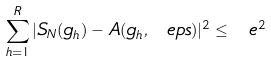Convert formula to latex. <formula><loc_0><loc_0><loc_500><loc_500>\sum _ { h = 1 } ^ { R } | S _ { N } ( g _ { h } ) - A ( g _ { h } , \ e p s ) | ^ { 2 } \leq \ e ^ { 2 }</formula> 